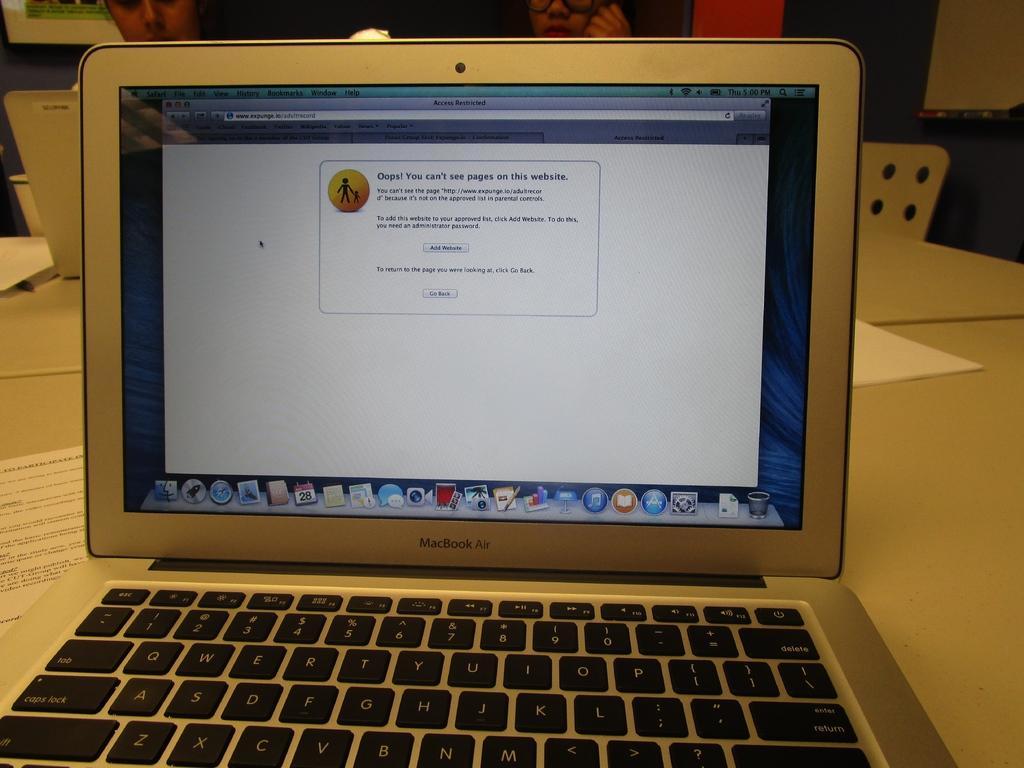Please provide a concise description of this image. This is the laptop with the display, which is placed on the table. At the top of the image, I can see another laptop and two people. These are the papers. I think this is the chair. 